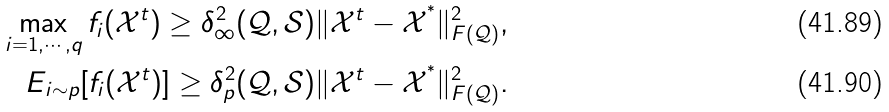Convert formula to latex. <formula><loc_0><loc_0><loc_500><loc_500>\max _ { i = 1 , \cdots , q } f _ { i } ( \mathcal { X } ^ { t } ) \geq \delta _ { \infty } ^ { 2 } ( \mathcal { Q } , \mathcal { S } ) \| \mathcal { X } ^ { t } - \mathcal { X } ^ { ^ { * } } \| _ { F ( \mathcal { Q } ) } ^ { 2 } , \\ E _ { i \sim p } [ f _ { i } ( \mathcal { X } ^ { t } ) ] \geq \delta _ { p } ^ { 2 } ( \mathcal { Q } , \mathcal { S } ) \| \mathcal { X } ^ { t } - \mathcal { X } ^ { ^ { * } } \| _ { F ( \mathcal { Q } ) } ^ { 2 } .</formula> 